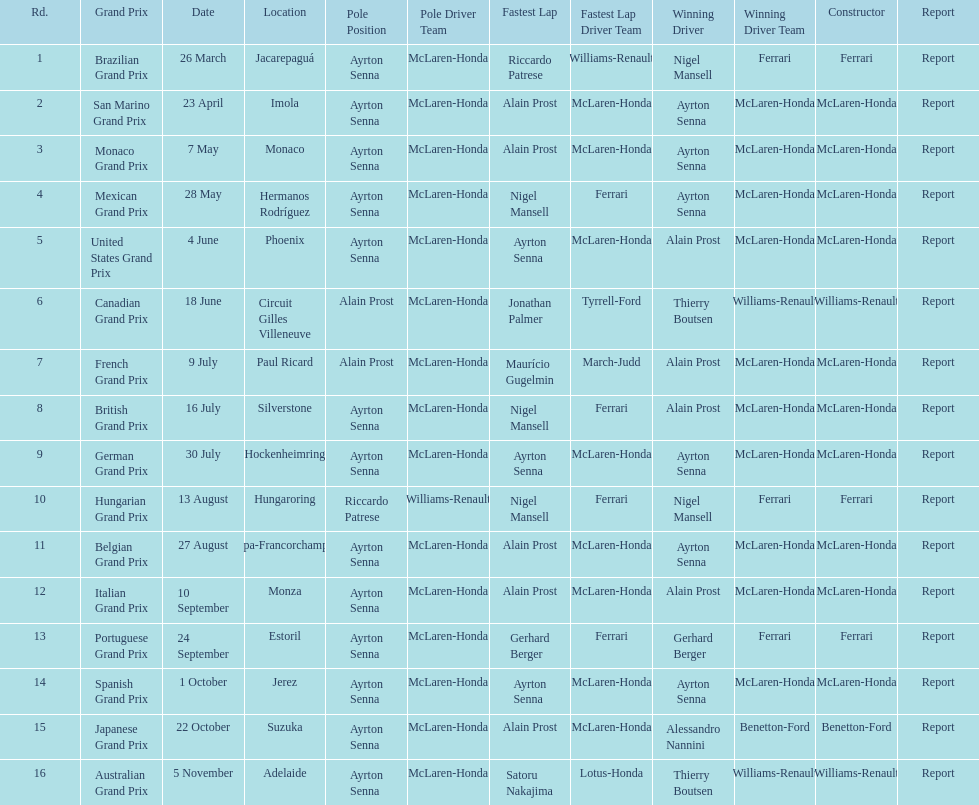How many times was ayrton senna in pole position? 13. 